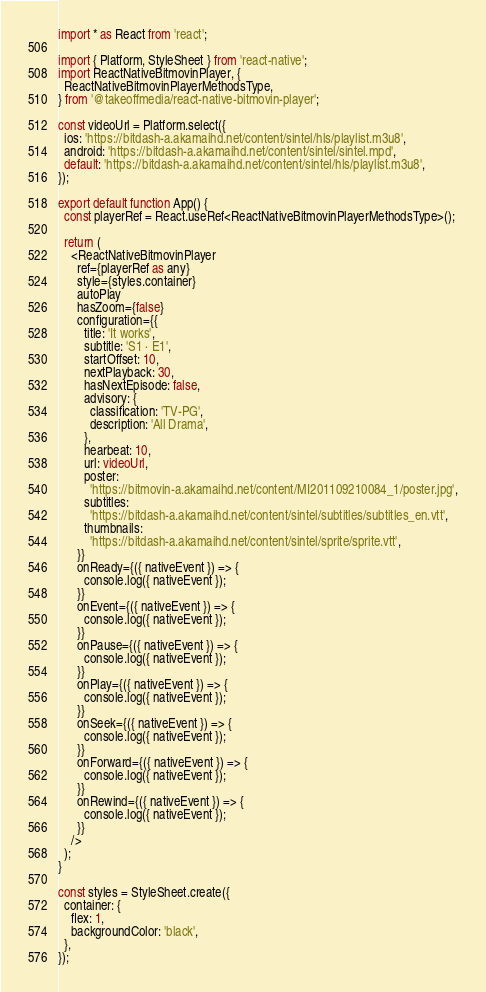<code> <loc_0><loc_0><loc_500><loc_500><_TypeScript_>import * as React from 'react';

import { Platform, StyleSheet } from 'react-native';
import ReactNativeBitmovinPlayer, {
  ReactNativeBitmovinPlayerMethodsType,
} from '@takeoffmedia/react-native-bitmovin-player';

const videoUrl = Platform.select({
  ios: 'https://bitdash-a.akamaihd.net/content/sintel/hls/playlist.m3u8',
  android: 'https://bitdash-a.akamaihd.net/content/sintel/sintel.mpd',
  default: 'https://bitdash-a.akamaihd.net/content/sintel/hls/playlist.m3u8',
});

export default function App() {
  const playerRef = React.useRef<ReactNativeBitmovinPlayerMethodsType>();

  return (
    <ReactNativeBitmovinPlayer
      ref={playerRef as any}
      style={styles.container}
      autoPlay
      hasZoom={false}
      configuration={{
        title: 'It works',
        subtitle: 'S1 · E1',
        startOffset: 10,
        nextPlayback: 30,
        hasNextEpisode: false,
        advisory: {
          classification: 'TV-PG',
          description: 'All Drama',
        },
        hearbeat: 10,
        url: videoUrl,
        poster:
          'https://bitmovin-a.akamaihd.net/content/MI201109210084_1/poster.jpg',
        subtitles:
          'https://bitdash-a.akamaihd.net/content/sintel/subtitles/subtitles_en.vtt',
        thumbnails:
          'https://bitdash-a.akamaihd.net/content/sintel/sprite/sprite.vtt',
      }}
      onReady={({ nativeEvent }) => {
        console.log({ nativeEvent });
      }}
      onEvent={({ nativeEvent }) => {
        console.log({ nativeEvent });
      }}
      onPause={({ nativeEvent }) => {
        console.log({ nativeEvent });
      }}
      onPlay={({ nativeEvent }) => {
        console.log({ nativeEvent });
      }}
      onSeek={({ nativeEvent }) => {
        console.log({ nativeEvent });
      }}
      onForward={({ nativeEvent }) => {
        console.log({ nativeEvent });
      }}
      onRewind={({ nativeEvent }) => {
        console.log({ nativeEvent });
      }}
    />
  );
}

const styles = StyleSheet.create({
  container: {
    flex: 1,
    backgroundColor: 'black',
  },
});
</code> 